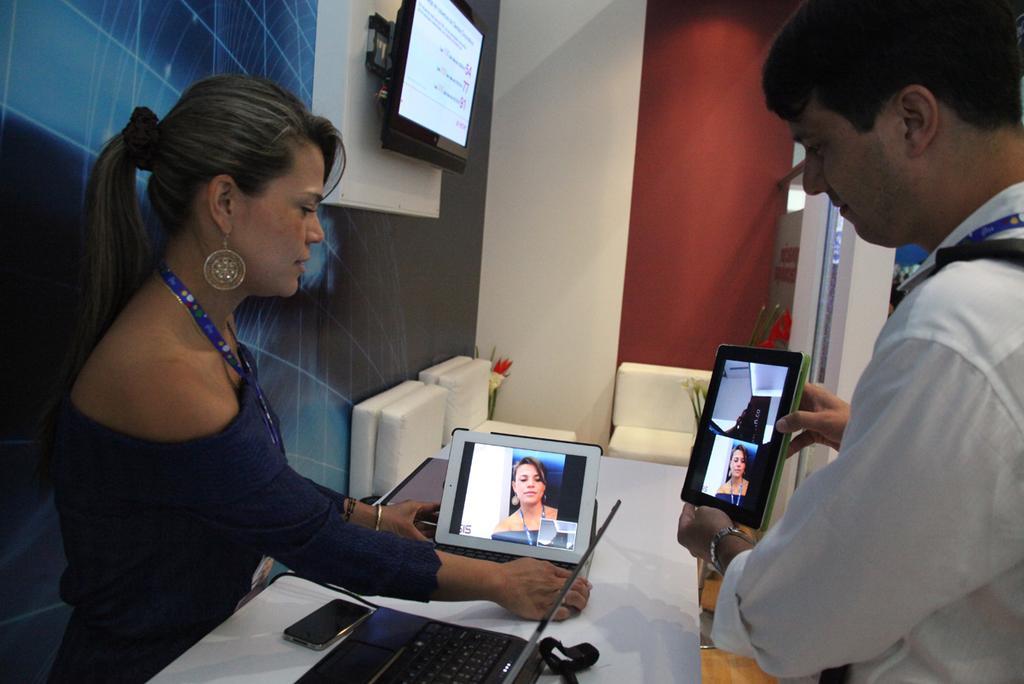Describe this image in one or two sentences. In this picture we can see a woman and a man. This is table. On the table there is a laptop, and a mobile. These are the airpods. There is a screen and this is wall. 